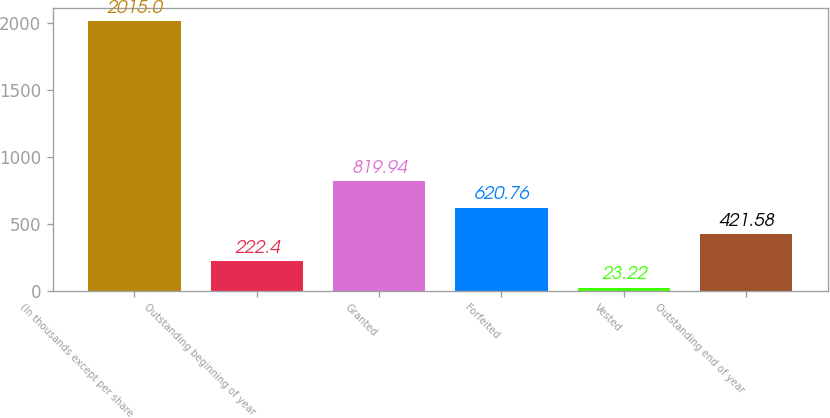Convert chart. <chart><loc_0><loc_0><loc_500><loc_500><bar_chart><fcel>(In thousands except per share<fcel>Outstanding beginning of year<fcel>Granted<fcel>Forfeited<fcel>Vested<fcel>Outstanding end of year<nl><fcel>2015<fcel>222.4<fcel>819.94<fcel>620.76<fcel>23.22<fcel>421.58<nl></chart> 